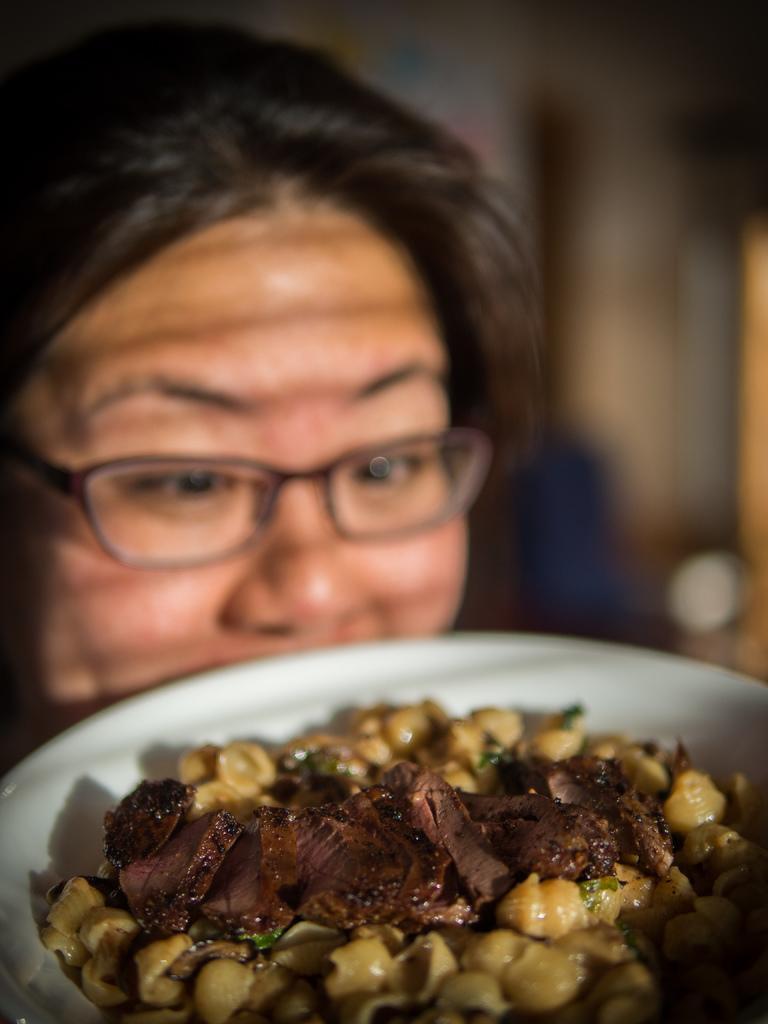In one or two sentences, can you explain what this image depicts? In this picture we can see a person with spectacles. In front of the person there is food in the white bowl. Behind the person there is the blurred background. 